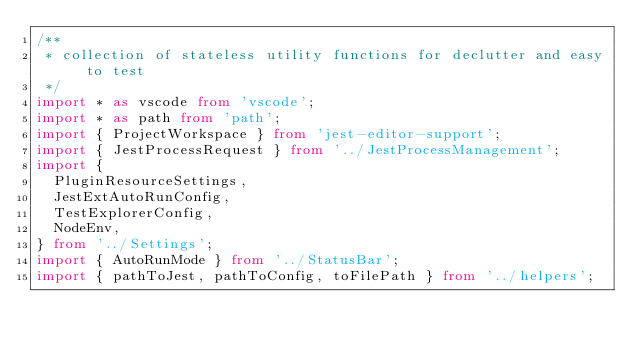<code> <loc_0><loc_0><loc_500><loc_500><_TypeScript_>/**
 * collection of stateless utility functions for declutter and easy to test
 */
import * as vscode from 'vscode';
import * as path from 'path';
import { ProjectWorkspace } from 'jest-editor-support';
import { JestProcessRequest } from '../JestProcessManagement';
import {
  PluginResourceSettings,
  JestExtAutoRunConfig,
  TestExplorerConfig,
  NodeEnv,
} from '../Settings';
import { AutoRunMode } from '../StatusBar';
import { pathToJest, pathToConfig, toFilePath } from '../helpers';</code> 